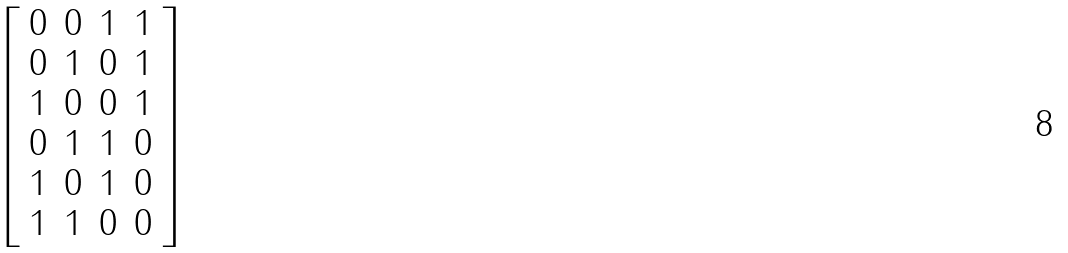Convert formula to latex. <formula><loc_0><loc_0><loc_500><loc_500>\left [ \begin{array} { c c c c } 0 & 0 & 1 & 1 \\ 0 & 1 & 0 & 1 \\ 1 & 0 & 0 & 1 \\ 0 & 1 & 1 & 0 \\ 1 & 0 & 1 & 0 \\ 1 & 1 & 0 & 0 \\ \end{array} \right ]</formula> 